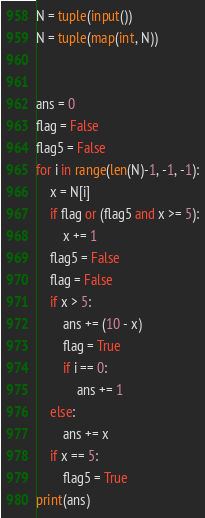<code> <loc_0><loc_0><loc_500><loc_500><_Python_>N = tuple(input())
N = tuple(map(int, N))


ans = 0
flag = False
flag5 = False
for i in range(len(N)-1, -1, -1):
    x = N[i]
    if flag or (flag5 and x >= 5):
        x += 1
    flag5 = False
    flag = False
    if x > 5:
        ans += (10 - x)
        flag = True
        if i == 0:
            ans += 1
    else:
        ans += x
    if x == 5:
        flag5 = True
print(ans)
</code> 